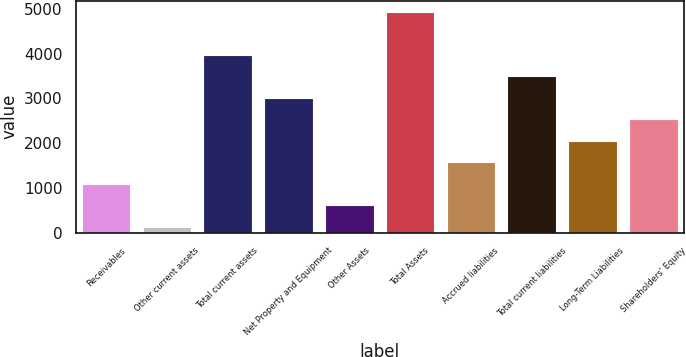<chart> <loc_0><loc_0><loc_500><loc_500><bar_chart><fcel>Receivables<fcel>Other current assets<fcel>Total current assets<fcel>Net Property and Equipment<fcel>Other Assets<fcel>Total Assets<fcel>Accrued liabilities<fcel>Total current liabilities<fcel>Long-Term Liabilities<fcel>Shareholders' Equity<nl><fcel>1099.2<fcel>139<fcel>3979.8<fcel>3019.6<fcel>619.1<fcel>4940<fcel>1579.3<fcel>3499.7<fcel>2059.4<fcel>2539.5<nl></chart> 